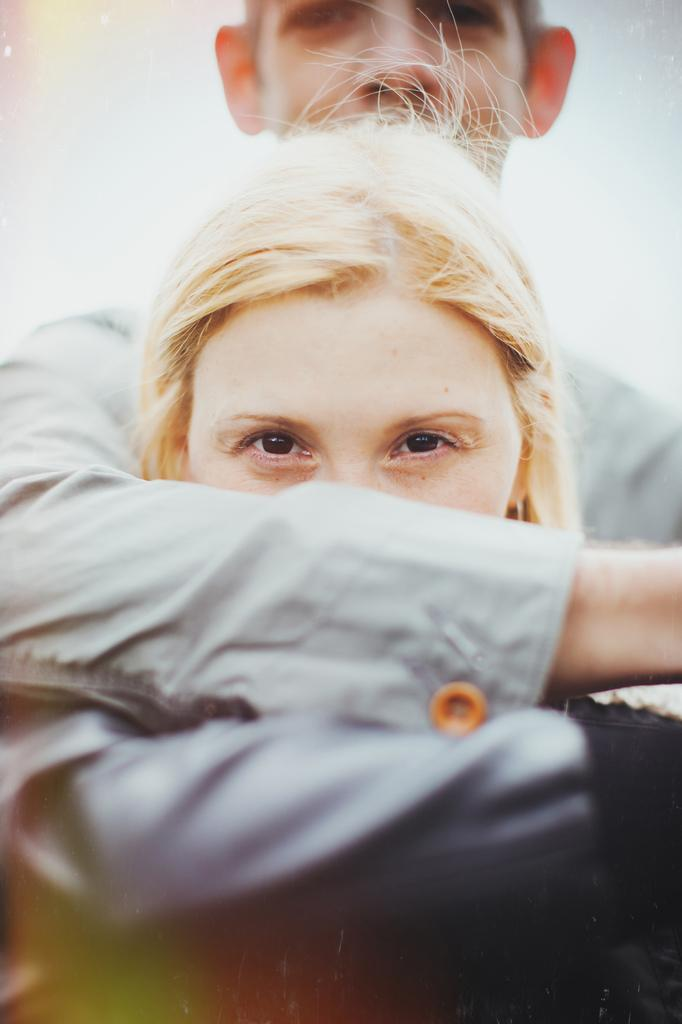How many people are present in the image? There are two people in the image, a man and a woman. What is the value of the pencil used by the man in the image? There is no pencil present in the image 